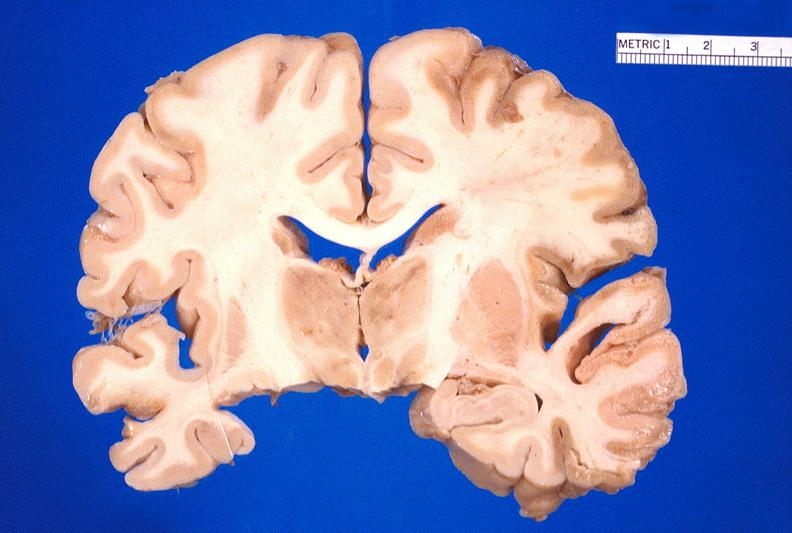does pituitectomy show brain, old infarcts, embolic?
Answer the question using a single word or phrase. No 